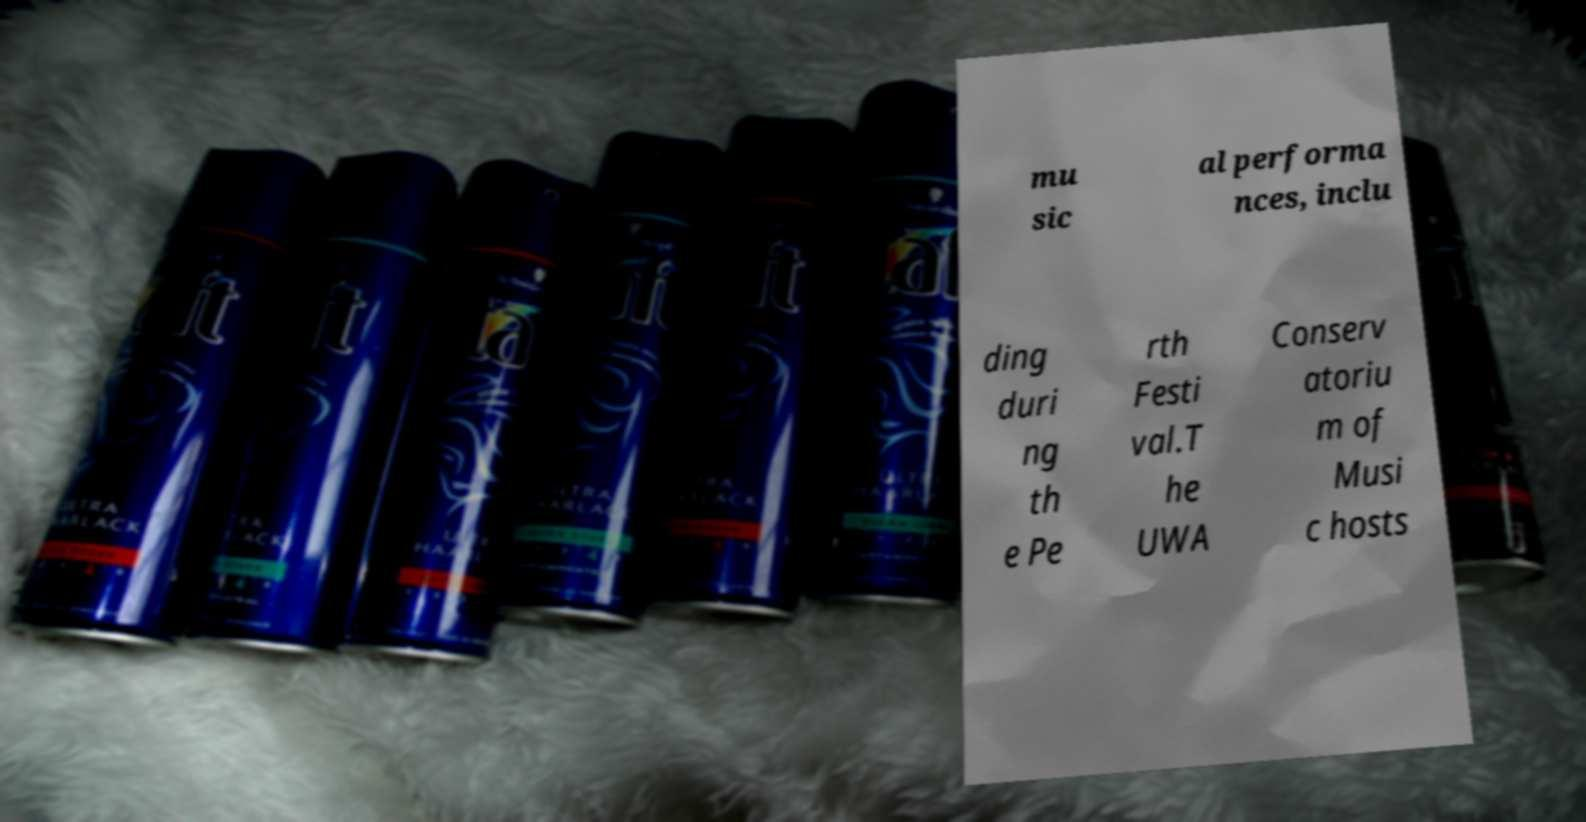For documentation purposes, I need the text within this image transcribed. Could you provide that? mu sic al performa nces, inclu ding duri ng th e Pe rth Festi val.T he UWA Conserv atoriu m of Musi c hosts 